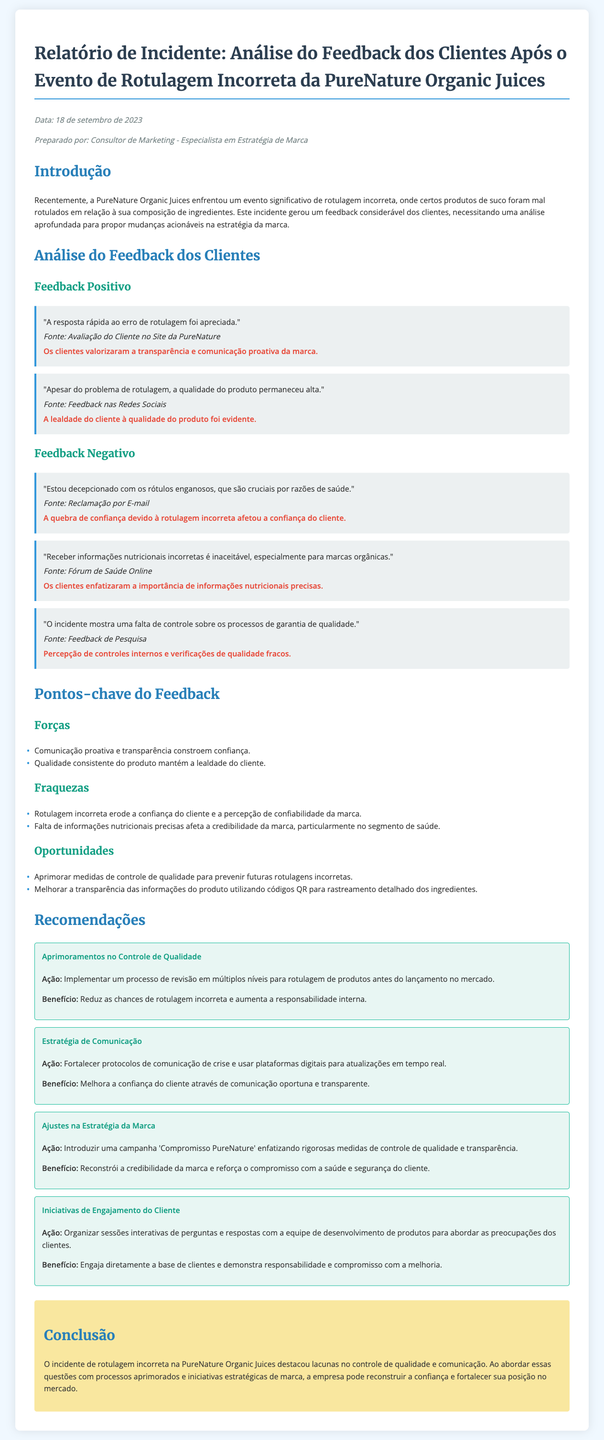qual é a data do relatório? A data do relatório é mencionada na seção "meta", que fornece detalhes sobre o documento.
Answer: 18 de setembro de 2023 quem preparou o relatório? A seção "meta" também indica quem preparou o relatório, mencionando o autor.
Answer: Consultor de Marketing - Especialista em Estratégia de Marca quais foram os pontos fortes identificados no feedback dos clientes? A seção "Pontos-chave do Feedback" lista os pontos fortes, que incluem aspectos que contribuem para a imagem da marca.
Answer: Comunicação proativa e transparência constroem confiança qual foi uma das fraquezas mencionadas no feedback? A seção "Fraquezas" descreve as deficiências percebidas que impactaram a marca negativamente.
Answer: Rotulagem incorreta erode a confiança do cliente e a percepção de confiabilidade da marca qual é uma das recomendações dadas no relatório? A seção "Recomendações" apresenta ações específicas propostas para melhorar a situação da marca.
Answer: Implementar um processo de revisão em múltiplos níveis para rotulagem de produtos como os clientes valorizaram a resposta da marca ao problema? A análise do feedback positivo descreve a percepção dos clientes sobre a reação da marque ao erro.
Answer: A resposta rápida ao erro de rotulagem foi apreciada o que o incidente destacou na PureNature Organic Juices? A conclusão resume os principais aprendizados do incidente e suas implicações para a empresa.
Answer: Lacunas no controle de qualidade e comunicação qual é o nome da marca envolvida no incidente de rotulagem? O título do relatório informa explicitamente sobre a marca em questão.
Answer: PureNature Organic Juices 